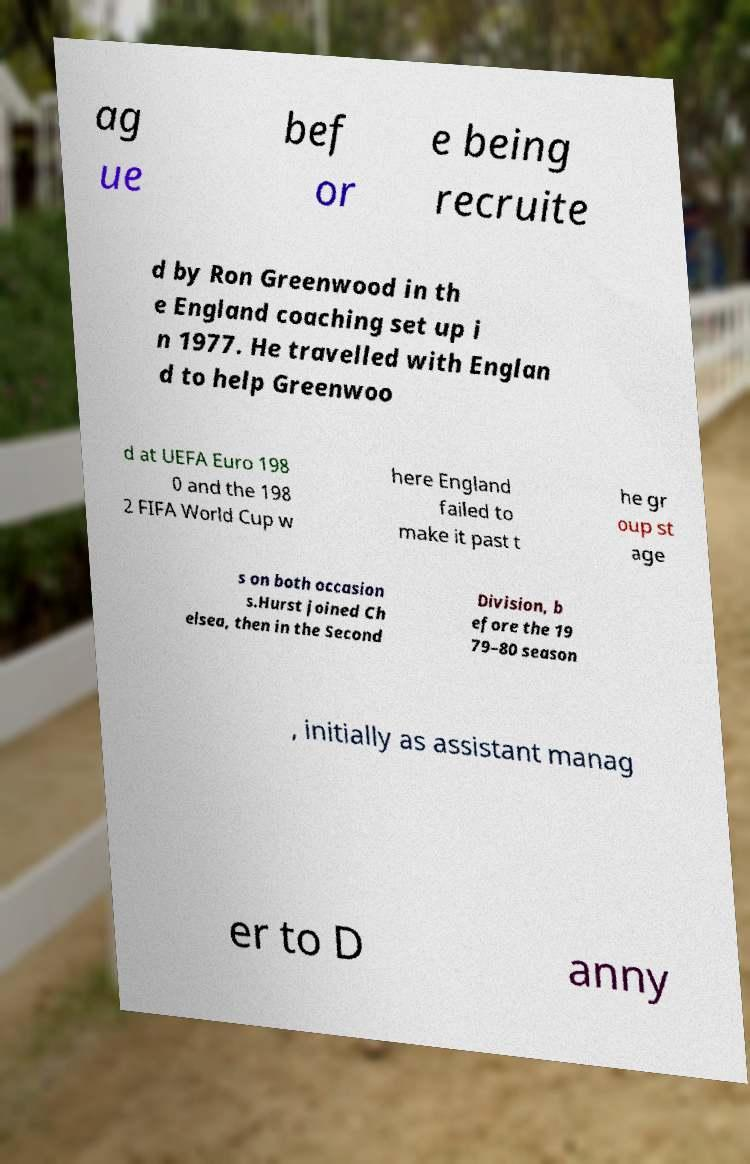Can you accurately transcribe the text from the provided image for me? ag ue bef or e being recruite d by Ron Greenwood in th e England coaching set up i n 1977. He travelled with Englan d to help Greenwoo d at UEFA Euro 198 0 and the 198 2 FIFA World Cup w here England failed to make it past t he gr oup st age s on both occasion s.Hurst joined Ch elsea, then in the Second Division, b efore the 19 79–80 season , initially as assistant manag er to D anny 